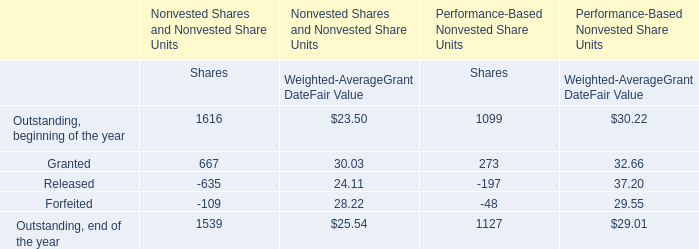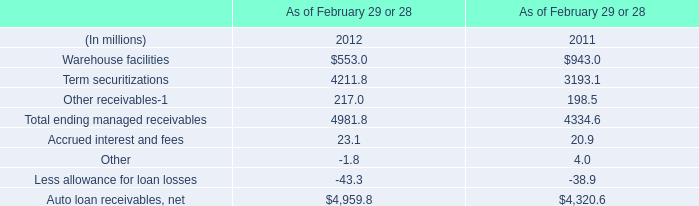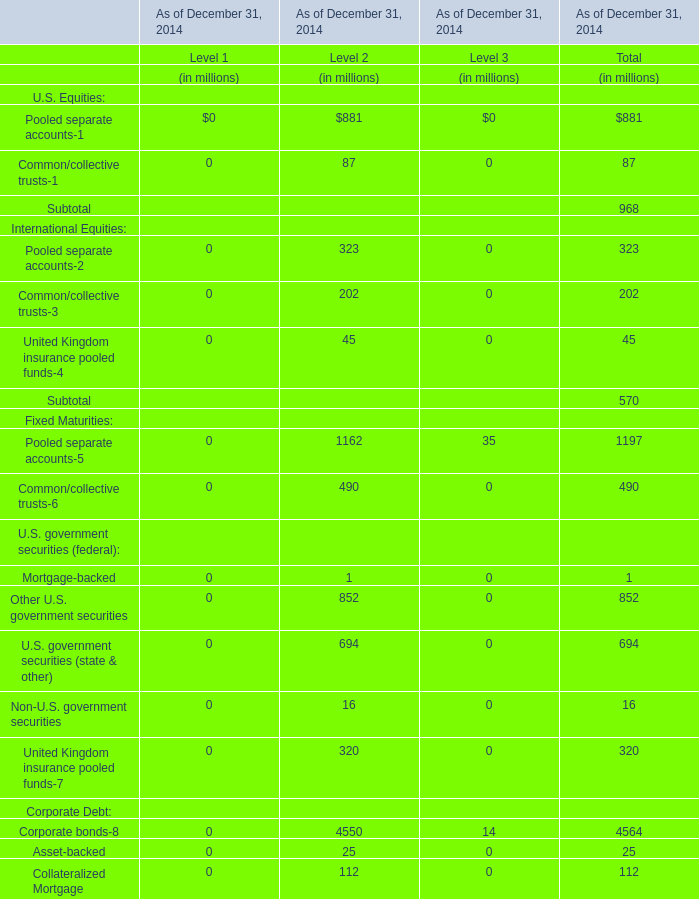What is the sum of Corporate bonds-8 of Level 2 in 2014 and Term securitizations in 2011? (in million) 
Computations: (4550 + 3193.1)
Answer: 7743.1. 